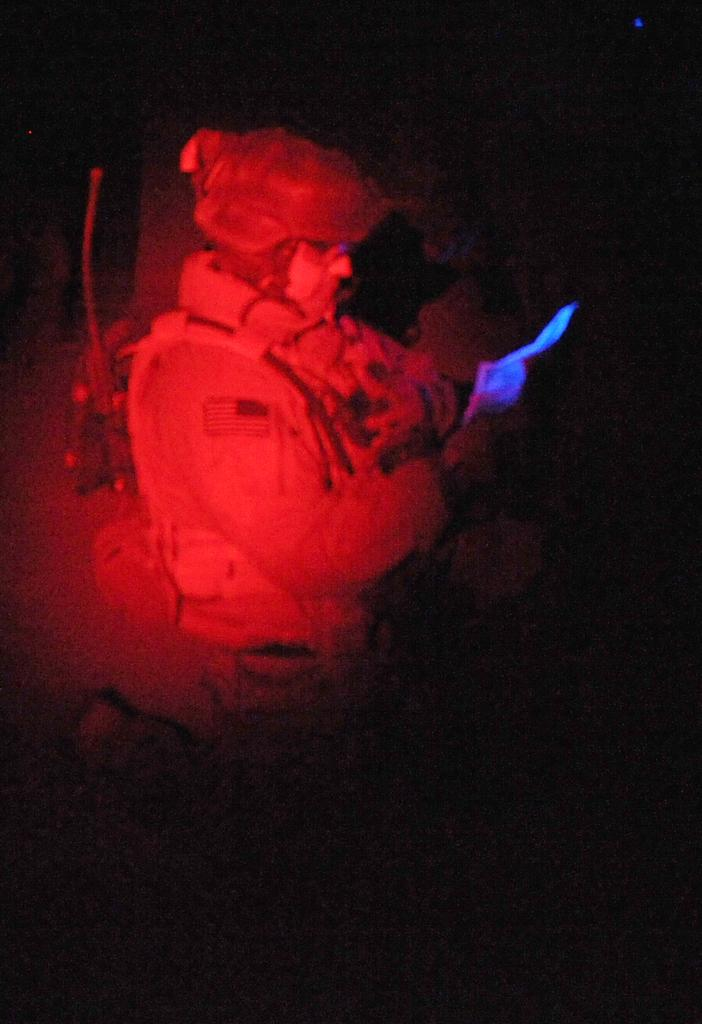Who is the main subject in the image? There is a person in the middle of the image. What is the person wearing on their head? The person is wearing a cap. What type of clothing is the person wearing? The person is wearing a dress. How many ants are crawling on the person's dress in the image? There are no ants present in the image; the person is wearing a dress and a cap. 